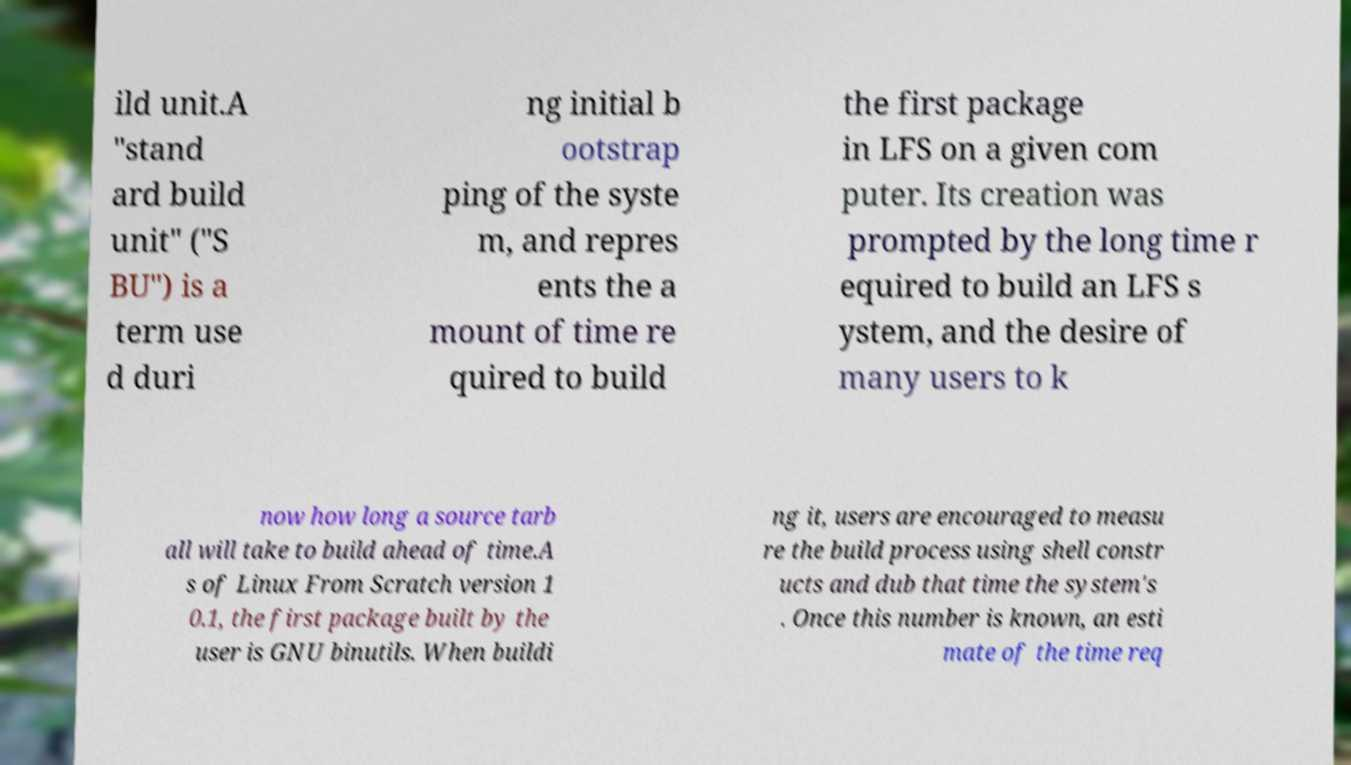Can you accurately transcribe the text from the provided image for me? ild unit.A "stand ard build unit" ("S BU") is a term use d duri ng initial b ootstrap ping of the syste m, and repres ents the a mount of time re quired to build the first package in LFS on a given com puter. Its creation was prompted by the long time r equired to build an LFS s ystem, and the desire of many users to k now how long a source tarb all will take to build ahead of time.A s of Linux From Scratch version 1 0.1, the first package built by the user is GNU binutils. When buildi ng it, users are encouraged to measu re the build process using shell constr ucts and dub that time the system's . Once this number is known, an esti mate of the time req 